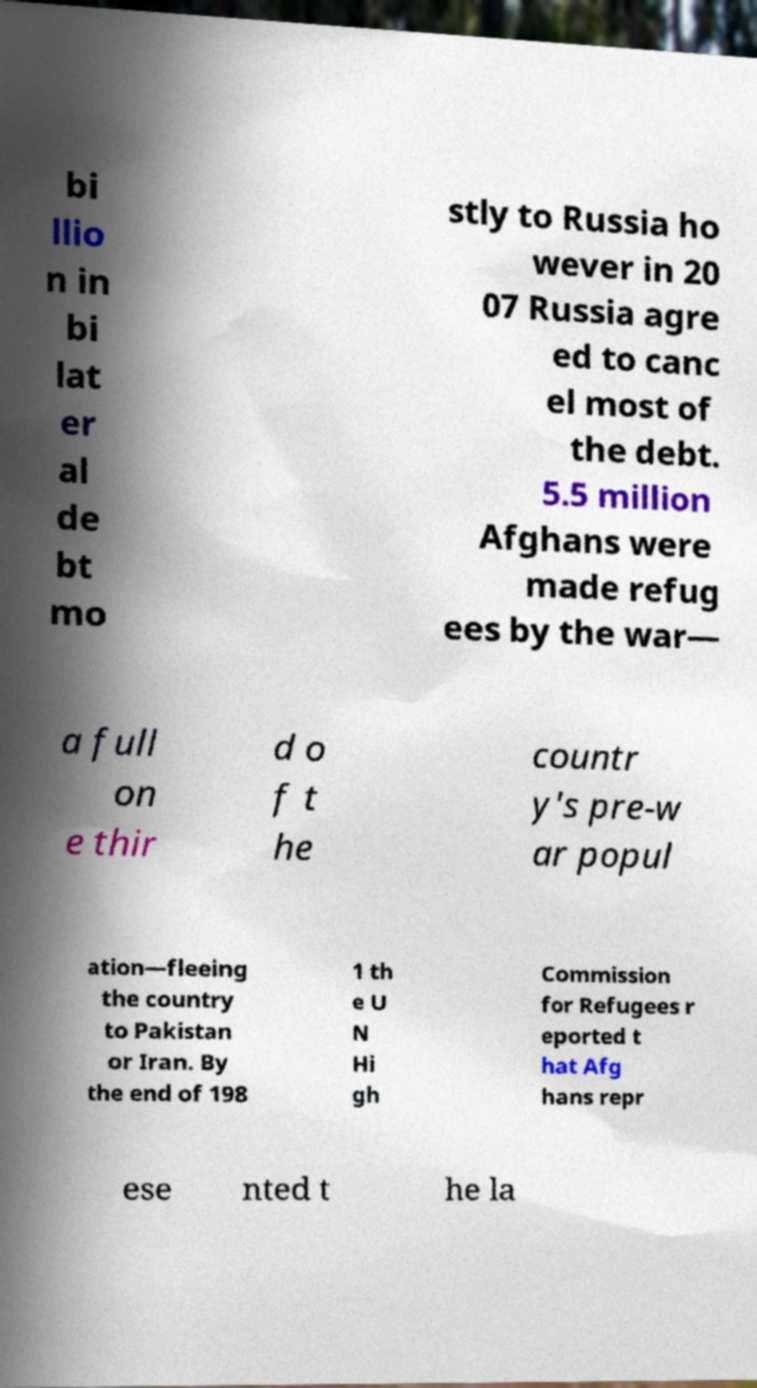Please read and relay the text visible in this image. What does it say? bi llio n in bi lat er al de bt mo stly to Russia ho wever in 20 07 Russia agre ed to canc el most of the debt. 5.5 million Afghans were made refug ees by the war— a full on e thir d o f t he countr y's pre-w ar popul ation—fleeing the country to Pakistan or Iran. By the end of 198 1 th e U N Hi gh Commission for Refugees r eported t hat Afg hans repr ese nted t he la 